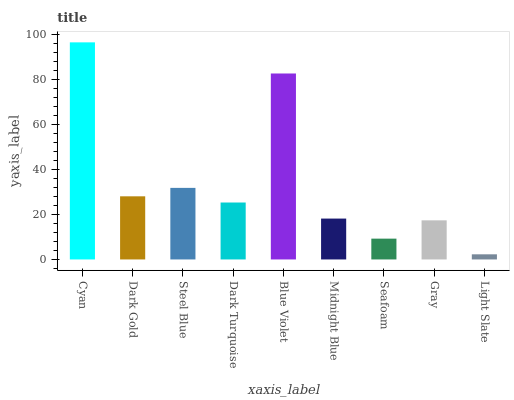Is Light Slate the minimum?
Answer yes or no. Yes. Is Cyan the maximum?
Answer yes or no. Yes. Is Dark Gold the minimum?
Answer yes or no. No. Is Dark Gold the maximum?
Answer yes or no. No. Is Cyan greater than Dark Gold?
Answer yes or no. Yes. Is Dark Gold less than Cyan?
Answer yes or no. Yes. Is Dark Gold greater than Cyan?
Answer yes or no. No. Is Cyan less than Dark Gold?
Answer yes or no. No. Is Dark Turquoise the high median?
Answer yes or no. Yes. Is Dark Turquoise the low median?
Answer yes or no. Yes. Is Light Slate the high median?
Answer yes or no. No. Is Steel Blue the low median?
Answer yes or no. No. 